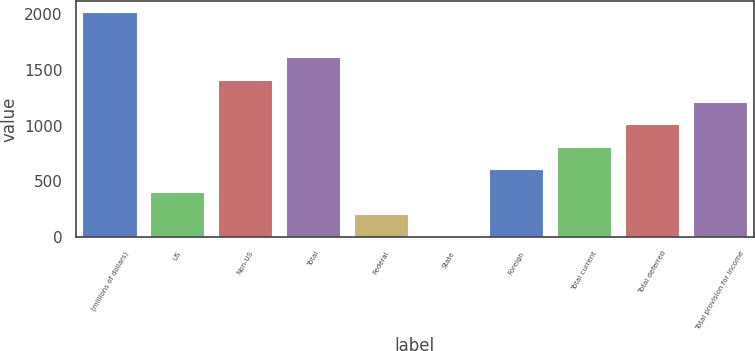<chart> <loc_0><loc_0><loc_500><loc_500><bar_chart><fcel>(millions of dollars)<fcel>US<fcel>Non-US<fcel>Total<fcel>Federal<fcel>State<fcel>Foreign<fcel>Total current<fcel>Total deferred<fcel>Total provision for income<nl><fcel>2017<fcel>407.08<fcel>1413.28<fcel>1614.52<fcel>205.84<fcel>4.6<fcel>608.32<fcel>809.56<fcel>1010.8<fcel>1212.04<nl></chart> 